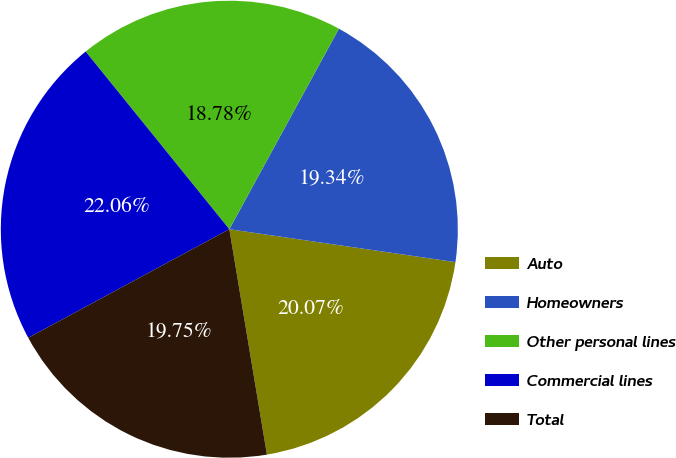<chart> <loc_0><loc_0><loc_500><loc_500><pie_chart><fcel>Auto<fcel>Homeowners<fcel>Other personal lines<fcel>Commercial lines<fcel>Total<nl><fcel>20.07%<fcel>19.34%<fcel>18.78%<fcel>22.06%<fcel>19.75%<nl></chart> 